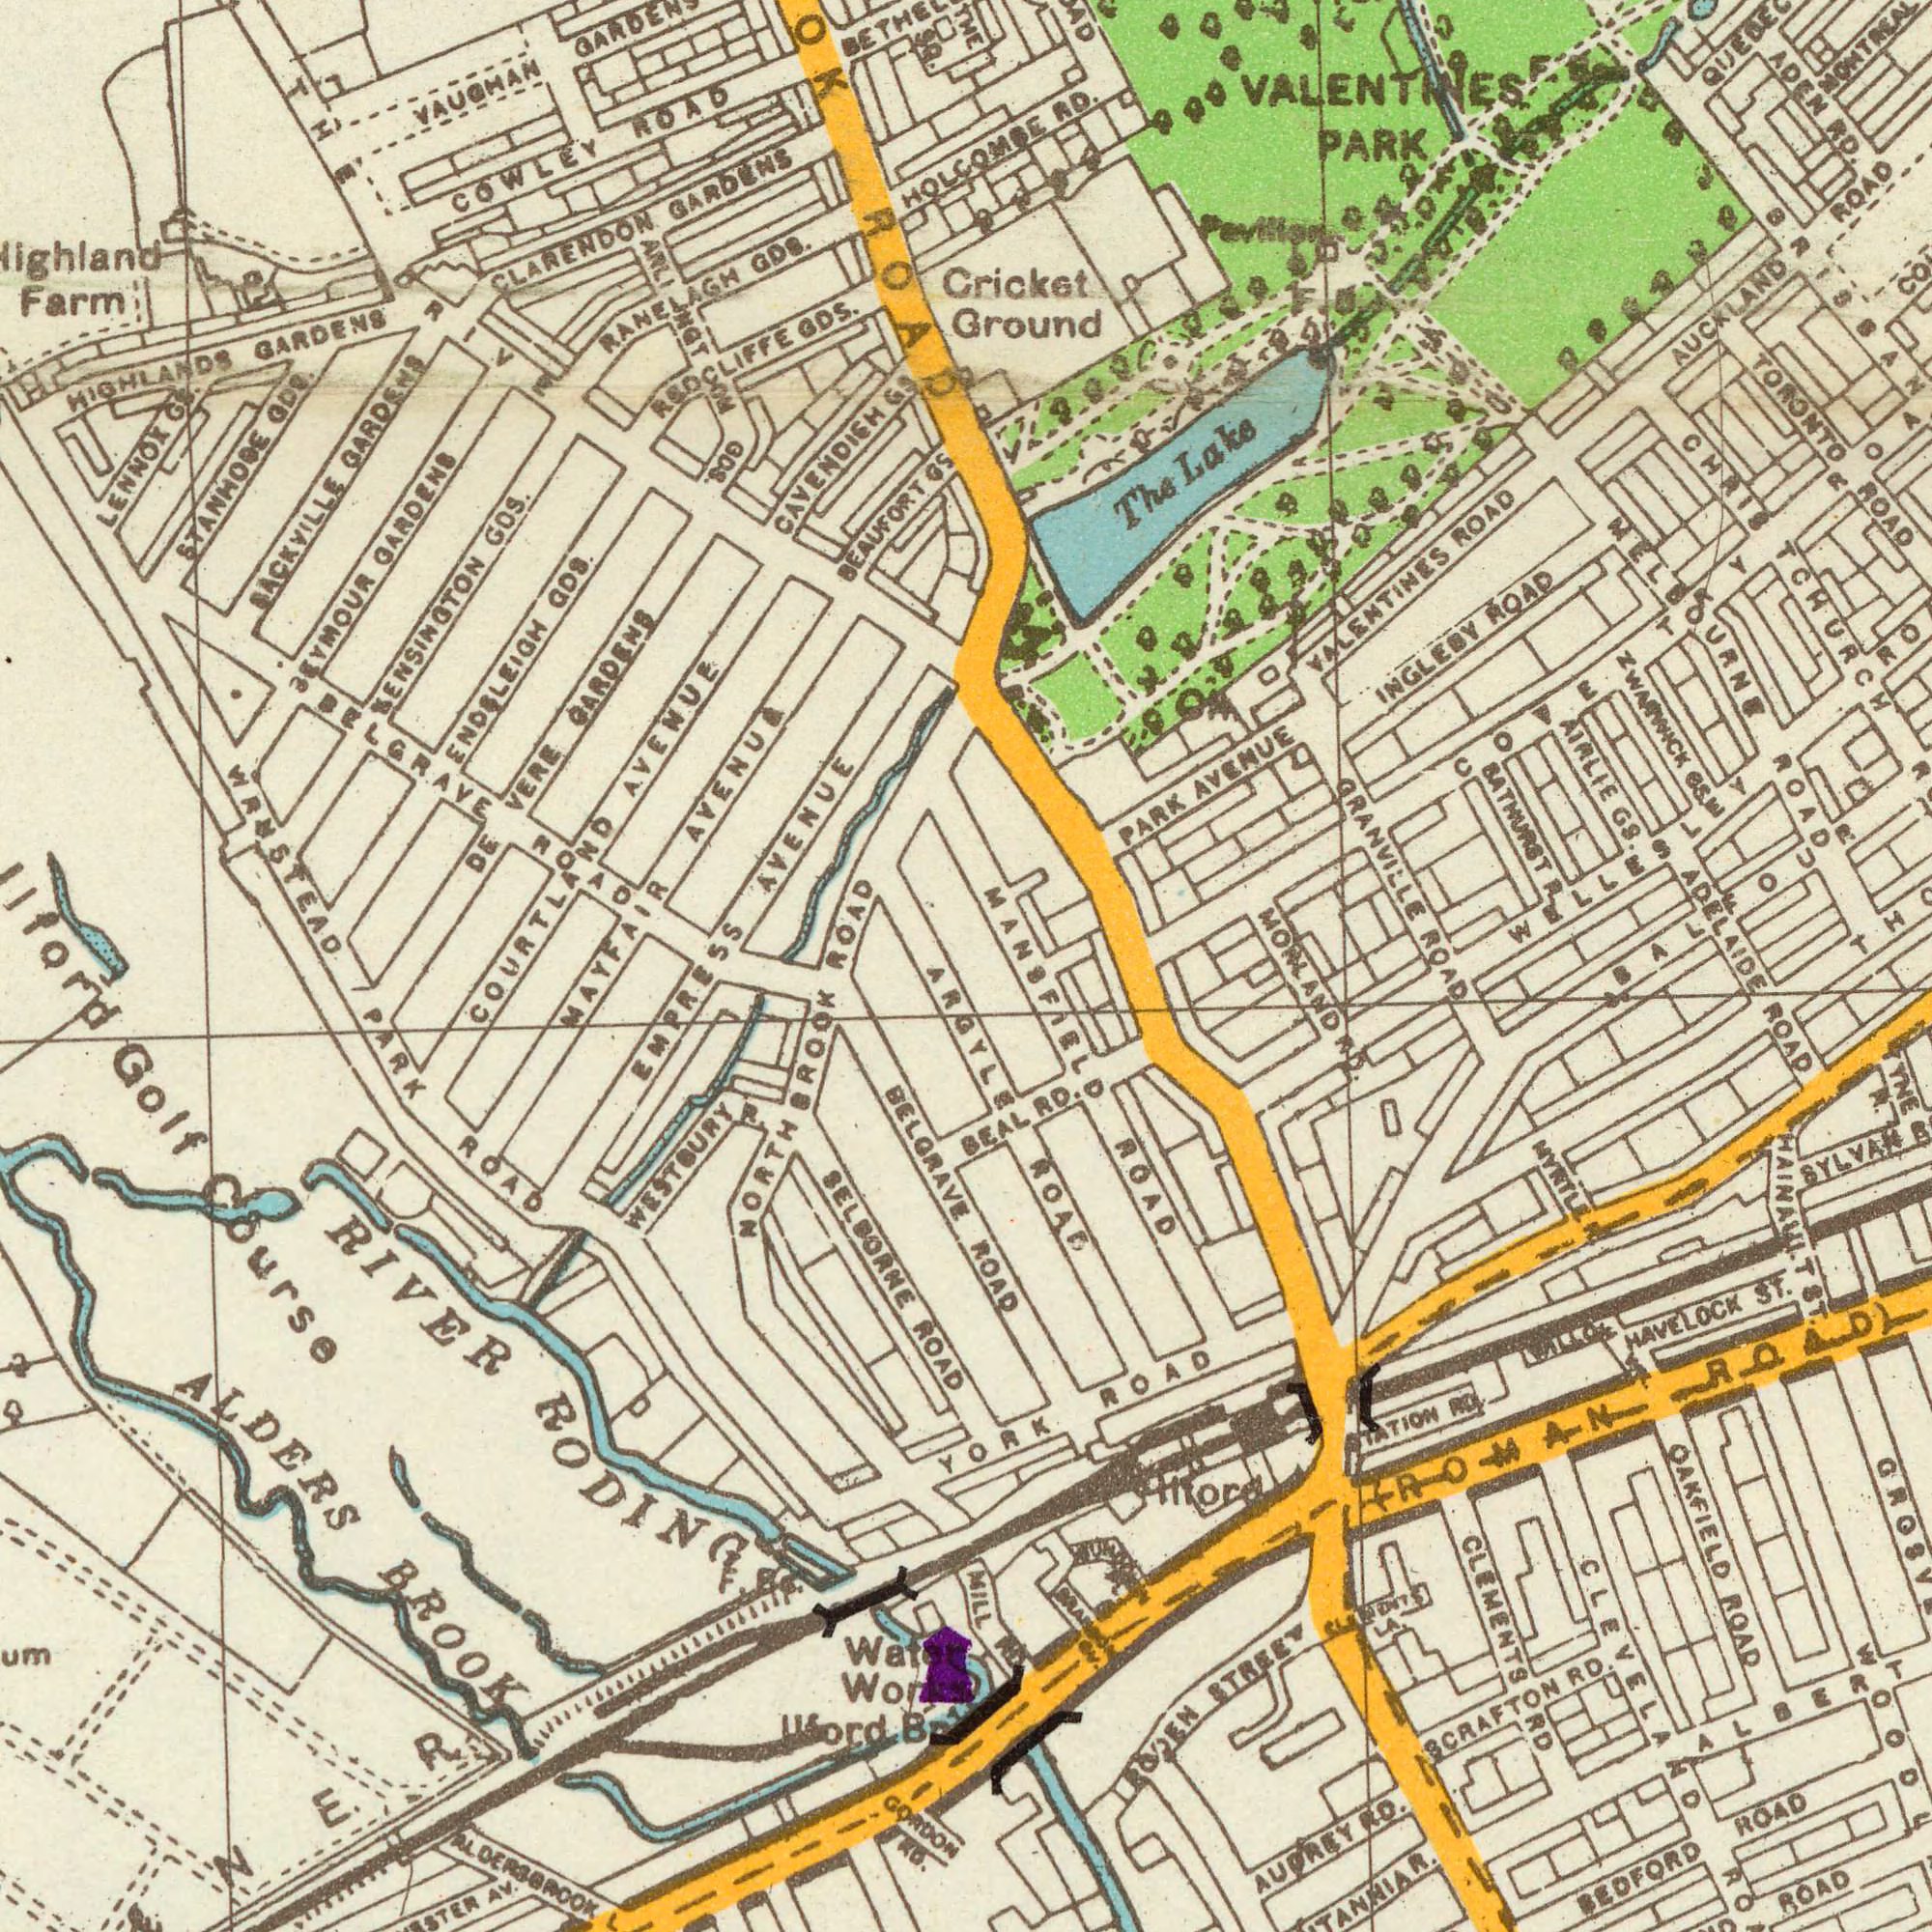What text is visible in the upper-right corner? GRANVILLE ROAD TORONTO ROAD Cricket Ground PARK AVENUE AIRLIE GS. VALENTINES ROAD INGLEBY ROAD AUCKLAND ROAD The Lake ADEN RD. RD. MELBOURNE ROAD BATHURST R. VALENTINES PARK MONTREAL QUEBEC BRISBANE ROAD ADELAIDE F. B. COVENTRY ROAD WARWICK GS. CHRISTCHURCH WELLESLEY ROAD BALFOUR Pavilion What text is shown in the bottom-right quadrant? ROAD CLEMENTS RD MANSFIELD ROAD YORK ROAD ROAE AUDREY RD. BEDFORD ROAD RUTLAND ROAD RODEN STREET OAKFIELD ROAD HAVELOCK ST. SYLVAN ROAD CLEVELAND ROAD SCRAFTON RD BEAL RD. MYRTLE R. HAINAULT ST. MILL RD ILFORD ALBERT BRITANNIA R. ###TATION RD. ROAD ###LLO YNE R. MORLAND RD. (ROMAN ROAD) CLEMENTS LA. ###A### ###U### What text can you see in the bottom-left section? PARK ROAD EMPRESS NORTHBROOK ALDERS BROOK SELBORNE ROAD WESTBURY R. RIVER RODING ALDERSBROOK Golf Course Water Works BELGRAVE GORDON RD. AV. ARGYLE Ilford B What text can you see in the top-left section? WANSTEAD CAVENDISH GS REDCLIFFE GDS. Farm LENNOX GS. BELGRAVE ROAD VAUGHAN SACKVILLE GARDENS SEYMOUR GARDENS KENSINGTON GDS. COURTLAND AVENUE AVENUE STANHOPE GDS. COWLEY ROAD HIGHLANDS GARDENS DE GARDENS ENDSLEIGH GDS. CLARENDON GARDENS ARLINGTON GDS. RANELAGH GDS. BEAUFORT GS ROAD BETHELL THE DRIVE MAYFAIR AVENUE HOLCOMBE ROAD THE SQ. 